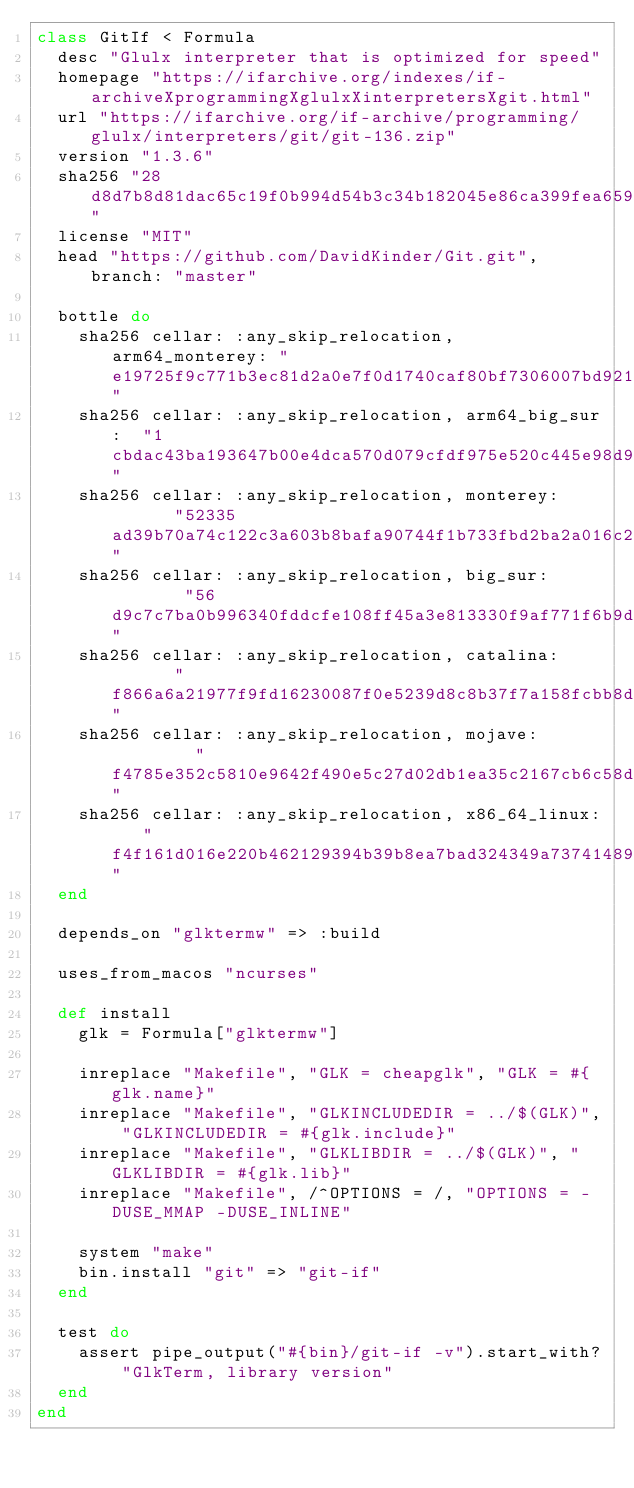<code> <loc_0><loc_0><loc_500><loc_500><_Ruby_>class GitIf < Formula
  desc "Glulx interpreter that is optimized for speed"
  homepage "https://ifarchive.org/indexes/if-archiveXprogrammingXglulxXinterpretersXgit.html"
  url "https://ifarchive.org/if-archive/programming/glulx/interpreters/git/git-136.zip"
  version "1.3.6"
  sha256 "28d8d7b8d81dac65c19f0b994d54b3c34b182045e86ca399fea65934918d1cf3"
  license "MIT"
  head "https://github.com/DavidKinder/Git.git", branch: "master"

  bottle do
    sha256 cellar: :any_skip_relocation, arm64_monterey: "e19725f9c771b3ec81d2a0e7f0d1740caf80bf7306007bd921e42e53ce56c506"
    sha256 cellar: :any_skip_relocation, arm64_big_sur:  "1cbdac43ba193647b00e4dca570d079cfdf975e520c445e98d9352d51100b91c"
    sha256 cellar: :any_skip_relocation, monterey:       "52335ad39b70a74c122c3a603b8bafa90744f1b733fbd2ba2a016c2c62b63842"
    sha256 cellar: :any_skip_relocation, big_sur:        "56d9c7c7ba0b996340fddcfe108ff45a3e813330f9af771f6b9d398be0b7129e"
    sha256 cellar: :any_skip_relocation, catalina:       "f866a6a21977f9fd16230087f0e5239d8c8b37f7a158fcbb8d257a225e222774"
    sha256 cellar: :any_skip_relocation, mojave:         "f4785e352c5810e9642f490e5c27d02db1ea35c2167cb6c58d88d55002501e7c"
    sha256 cellar: :any_skip_relocation, x86_64_linux:   "f4f161d016e220b462129394b39b8ea7bad324349a73741489d3c6ea8d65f2db"
  end

  depends_on "glktermw" => :build

  uses_from_macos "ncurses"

  def install
    glk = Formula["glktermw"]

    inreplace "Makefile", "GLK = cheapglk", "GLK = #{glk.name}"
    inreplace "Makefile", "GLKINCLUDEDIR = ../$(GLK)", "GLKINCLUDEDIR = #{glk.include}"
    inreplace "Makefile", "GLKLIBDIR = ../$(GLK)", "GLKLIBDIR = #{glk.lib}"
    inreplace "Makefile", /^OPTIONS = /, "OPTIONS = -DUSE_MMAP -DUSE_INLINE"

    system "make"
    bin.install "git" => "git-if"
  end

  test do
    assert pipe_output("#{bin}/git-if -v").start_with? "GlkTerm, library version"
  end
end
</code> 